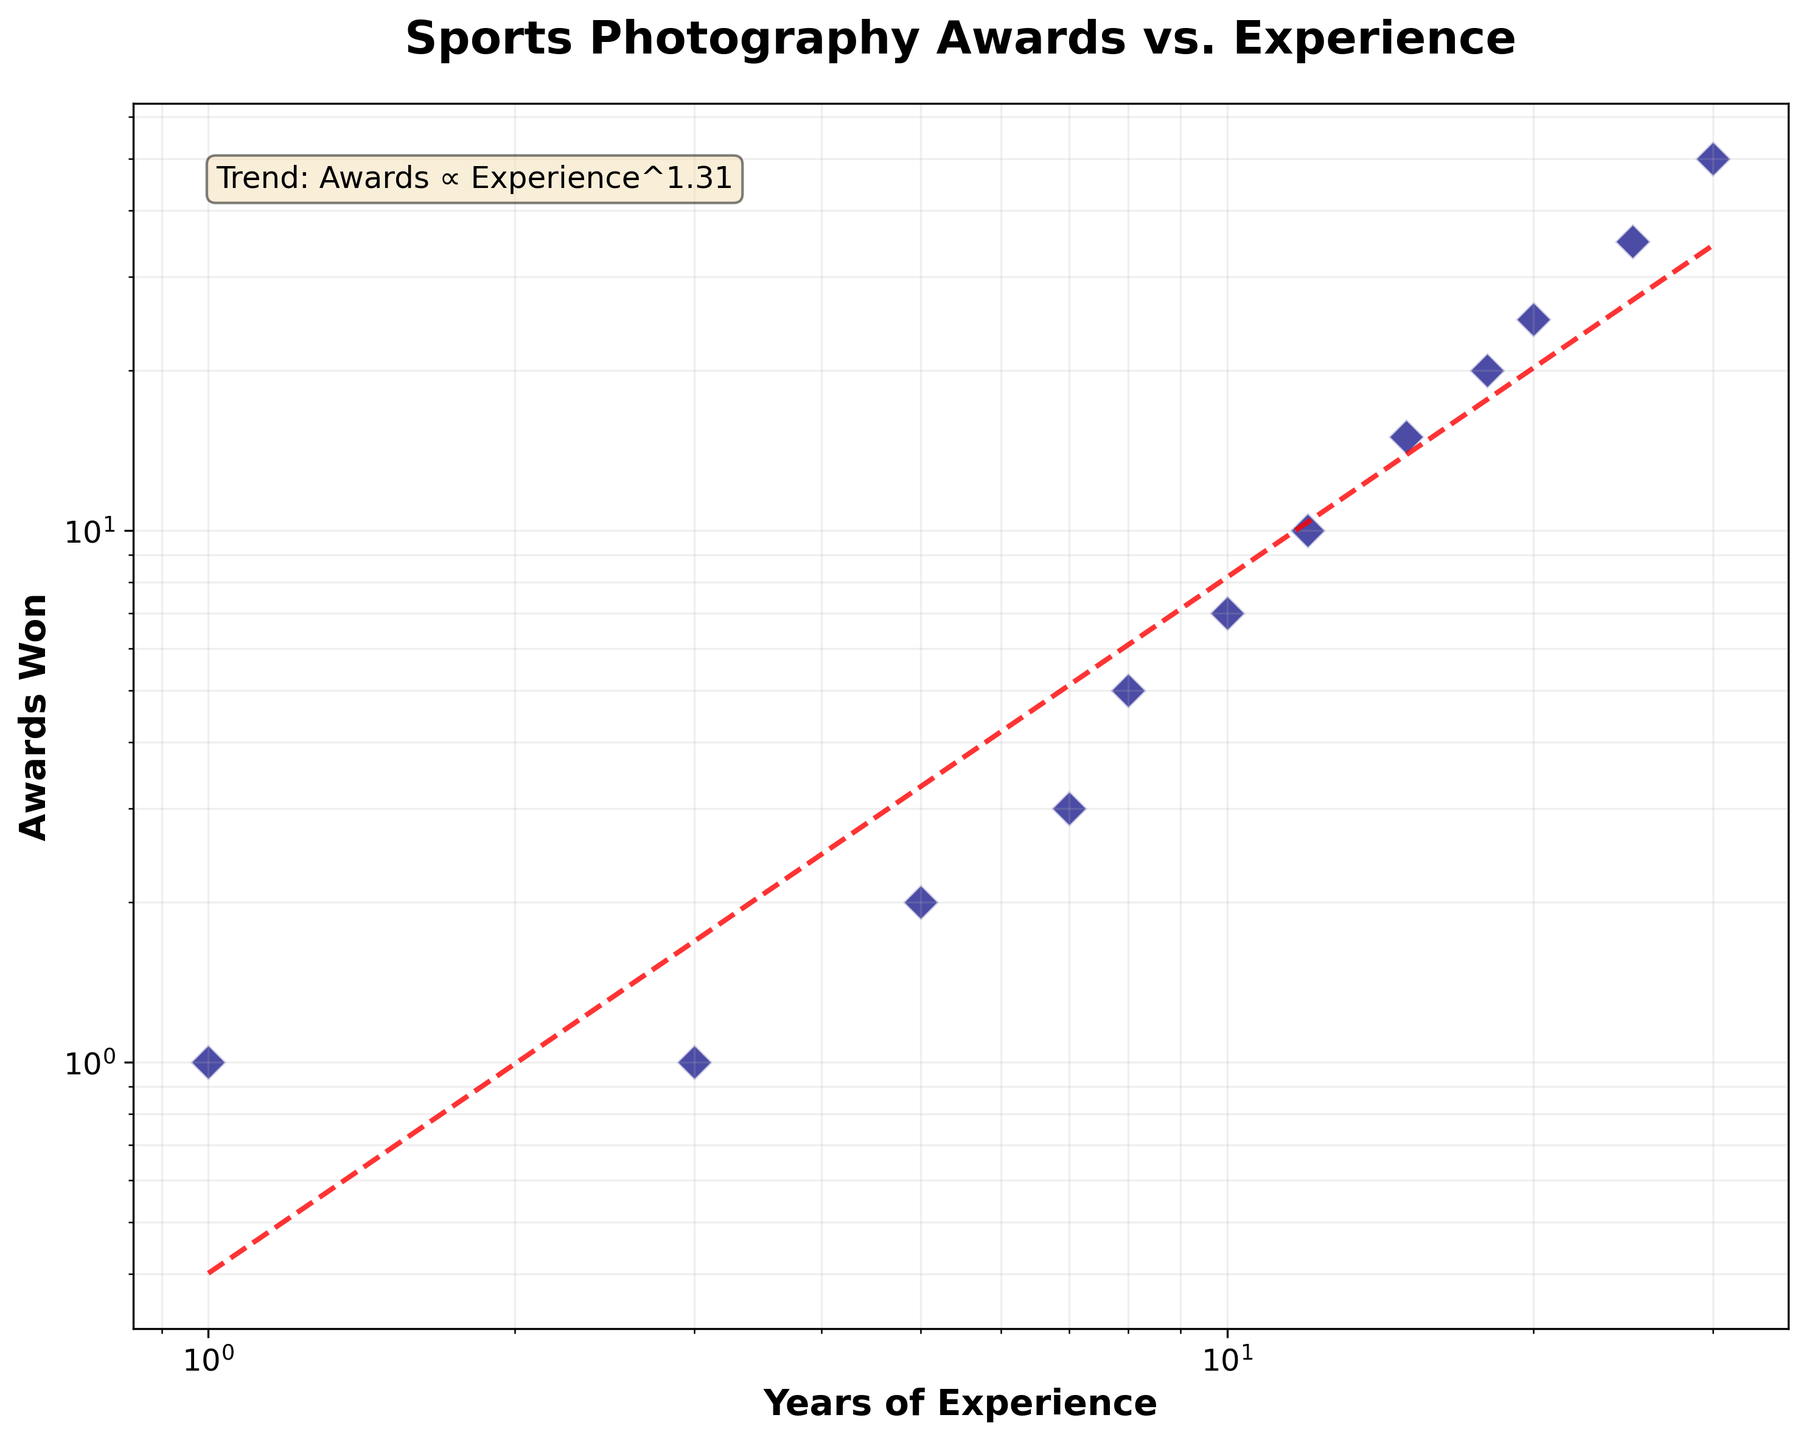What's the title of the plot? The title is located at the top center of the plot, and it states "Sports Photography Awards vs. Experience".
Answer: Sports Photography Awards vs. Experience Which data points have the smallest value for Years of Experience and Awards Won? The data point with 1 year of experience and 1 award has the smallest values, located at the bottom left of the plot.
Answer: 1 year of experience, 1 award How many data points are shown in the plot? By counting each distinct dot, we find that there are a total of 12 data points in the scatter plot.
Answer: 12 What is the label for the x-axis? The label for the x-axis can be seen below the horizontal axis and it reads "Years of Experience".
Answer: Years of Experience What is the relationship between the Years of Experience and Awards Won according to the trend line? The trend line indicates a positive correlation: as the years of experience increase, the number of awards won also increases.
Answer: Positive correlation Compare the awards won at 5 years of experience and 10 years of experience. Which is greater and by how much? The plot shows that 2 awards were won at 5 years of experience and 7 awards at 10 years. The difference is 7 - 2 = 5.
Answer: 5 awards Approximately how many awards are expected to be won with 20 years of experience according to the trend line? The trend line suggests that around 25 awards are won at 20 years of experience, as indicated by the plotted data and trend line.
Answer: 25 awards What does the annotation "Trend: Awards ∝ Experience^{0.87}" suggest about the data? The annotation means that the number of awards won increases proportionally to the years of experience raised to the power of approximately 0.87, indicating a sublinear growth.
Answer: Sublinear growth Which year of experience corresponds to approximately 15 awards won? By examining the data points and their distribution on the plot, 15 years of experience corresponds to approximately 15 awards.
Answer: 15 years How many awards are won by the most experienced individual in the dataset? The plot shows that the most experienced individual, with 30 years, won about 50 awards, as indicated by the data point furthest to the right.
Answer: 50 awards 